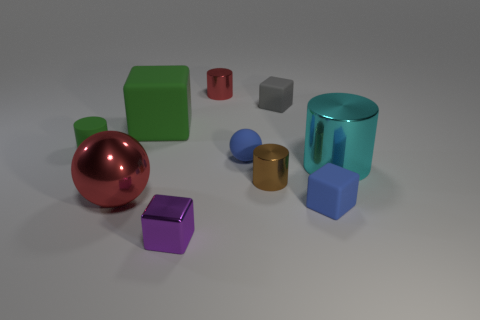Subtract 1 blocks. How many blocks are left? 3 Subtract all green cubes. How many cubes are left? 3 Subtract all yellow cubes. Subtract all green spheres. How many cubes are left? 4 Subtract all cylinders. How many objects are left? 6 Subtract 0 yellow cylinders. How many objects are left? 10 Subtract all small gray matte cubes. Subtract all small cubes. How many objects are left? 6 Add 8 red cylinders. How many red cylinders are left? 9 Add 1 green cylinders. How many green cylinders exist? 2 